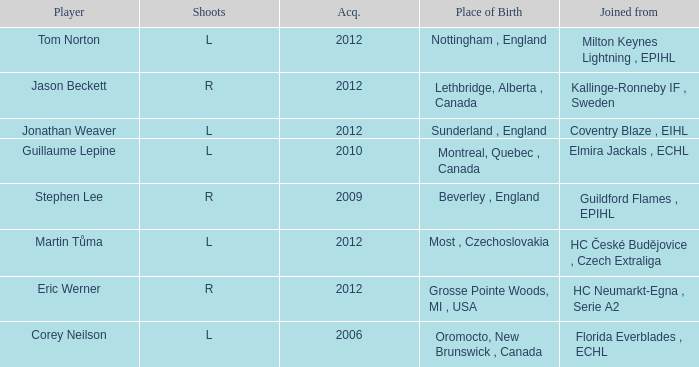Who acquired tom norton? 2012.0. 